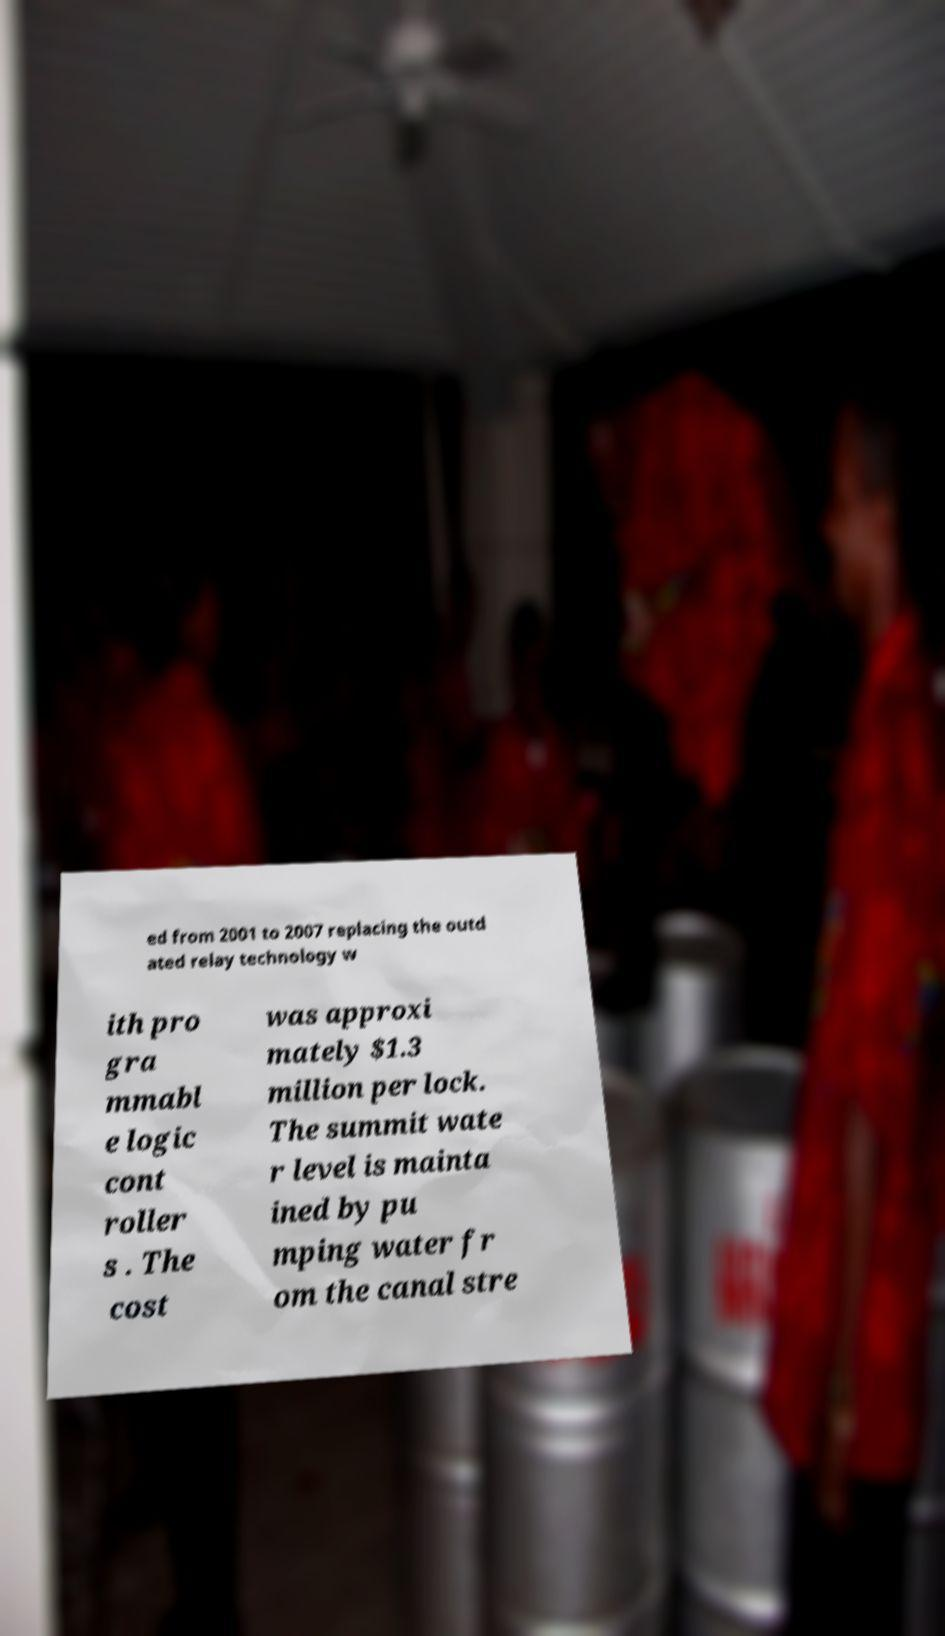Can you read and provide the text displayed in the image?This photo seems to have some interesting text. Can you extract and type it out for me? ed from 2001 to 2007 replacing the outd ated relay technology w ith pro gra mmabl e logic cont roller s . The cost was approxi mately $1.3 million per lock. The summit wate r level is mainta ined by pu mping water fr om the canal stre 